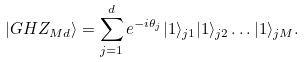<formula> <loc_0><loc_0><loc_500><loc_500>| G H Z _ { M d } \rangle = \sum _ { j = 1 } ^ { d } e ^ { - i \theta _ { j } } | 1 \rangle _ { j 1 } | 1 \rangle _ { j 2 } \dots | 1 \rangle _ { j M } .</formula> 